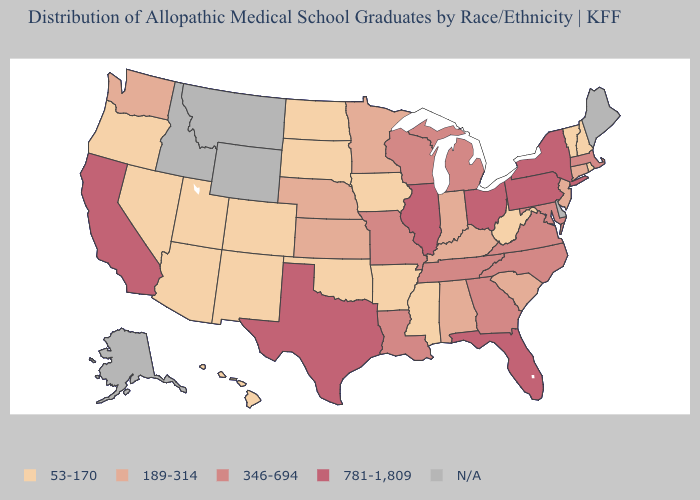Does the first symbol in the legend represent the smallest category?
Be succinct. Yes. Does New Jersey have the highest value in the USA?
Give a very brief answer. No. Among the states that border Arizona , which have the lowest value?
Be succinct. Colorado, Nevada, New Mexico, Utah. What is the value of New York?
Keep it brief. 781-1,809. What is the highest value in the MidWest ?
Give a very brief answer. 781-1,809. Does Arizona have the lowest value in the USA?
Concise answer only. Yes. What is the value of Tennessee?
Keep it brief. 346-694. What is the value of Idaho?
Give a very brief answer. N/A. Name the states that have a value in the range N/A?
Keep it brief. Alaska, Delaware, Idaho, Maine, Montana, Wyoming. What is the value of Massachusetts?
Answer briefly. 346-694. What is the value of Georgia?
Be succinct. 346-694. Is the legend a continuous bar?
Be succinct. No. Does West Virginia have the lowest value in the South?
Short answer required. Yes. What is the value of Ohio?
Short answer required. 781-1,809. Which states have the lowest value in the MidWest?
Keep it brief. Iowa, North Dakota, South Dakota. 